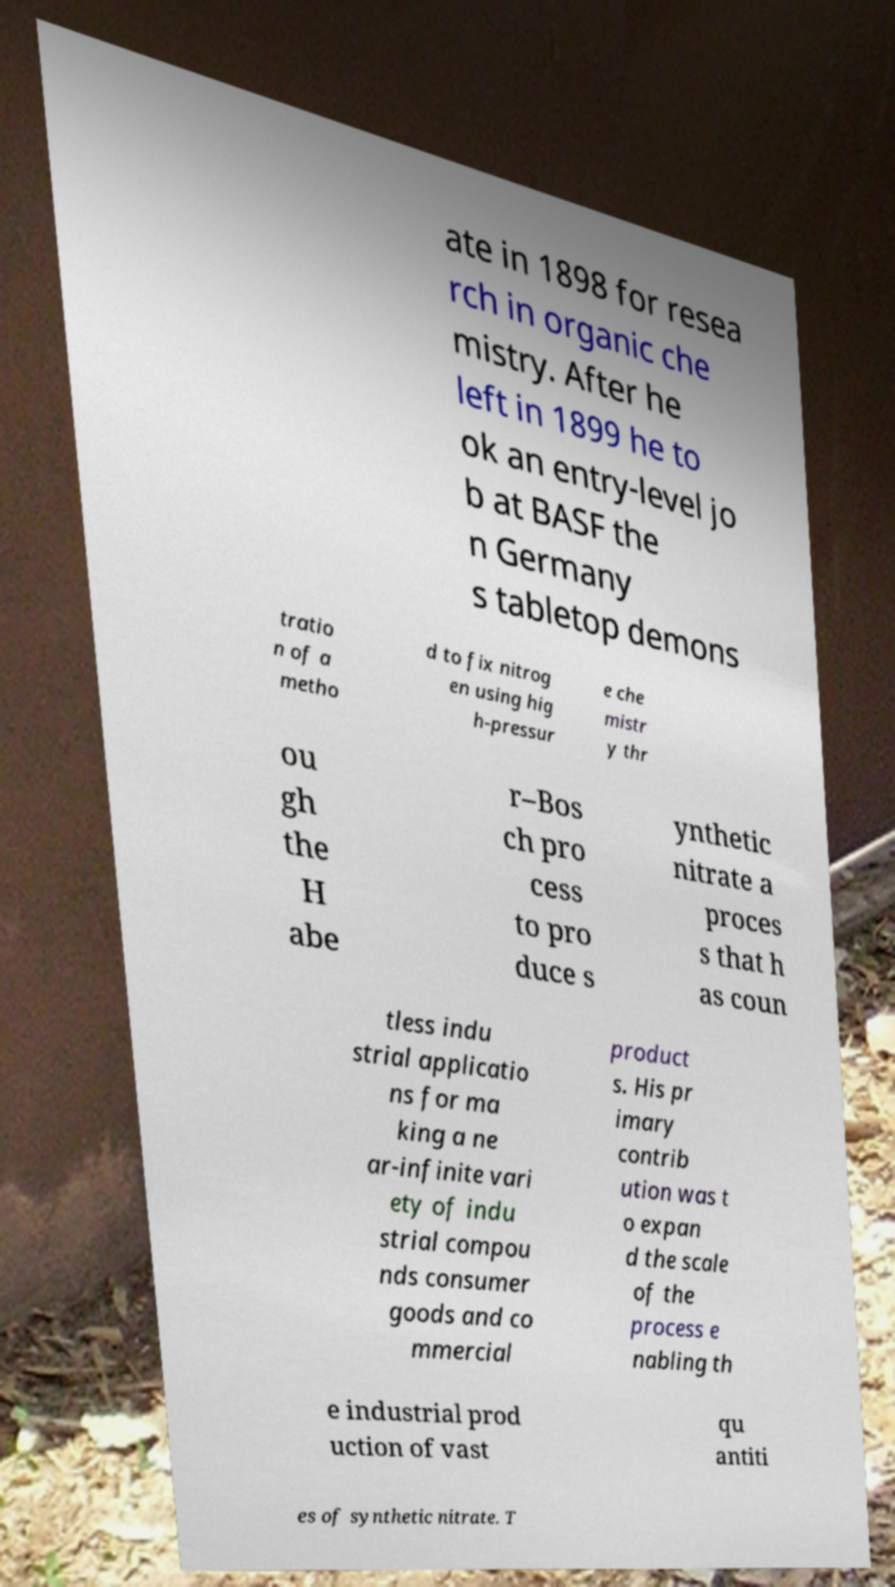For documentation purposes, I need the text within this image transcribed. Could you provide that? ate in 1898 for resea rch in organic che mistry. After he left in 1899 he to ok an entry-level jo b at BASF the n Germany s tabletop demons tratio n of a metho d to fix nitrog en using hig h-pressur e che mistr y thr ou gh the H abe r–Bos ch pro cess to pro duce s ynthetic nitrate a proces s that h as coun tless indu strial applicatio ns for ma king a ne ar-infinite vari ety of indu strial compou nds consumer goods and co mmercial product s. His pr imary contrib ution was t o expan d the scale of the process e nabling th e industrial prod uction of vast qu antiti es of synthetic nitrate. T 